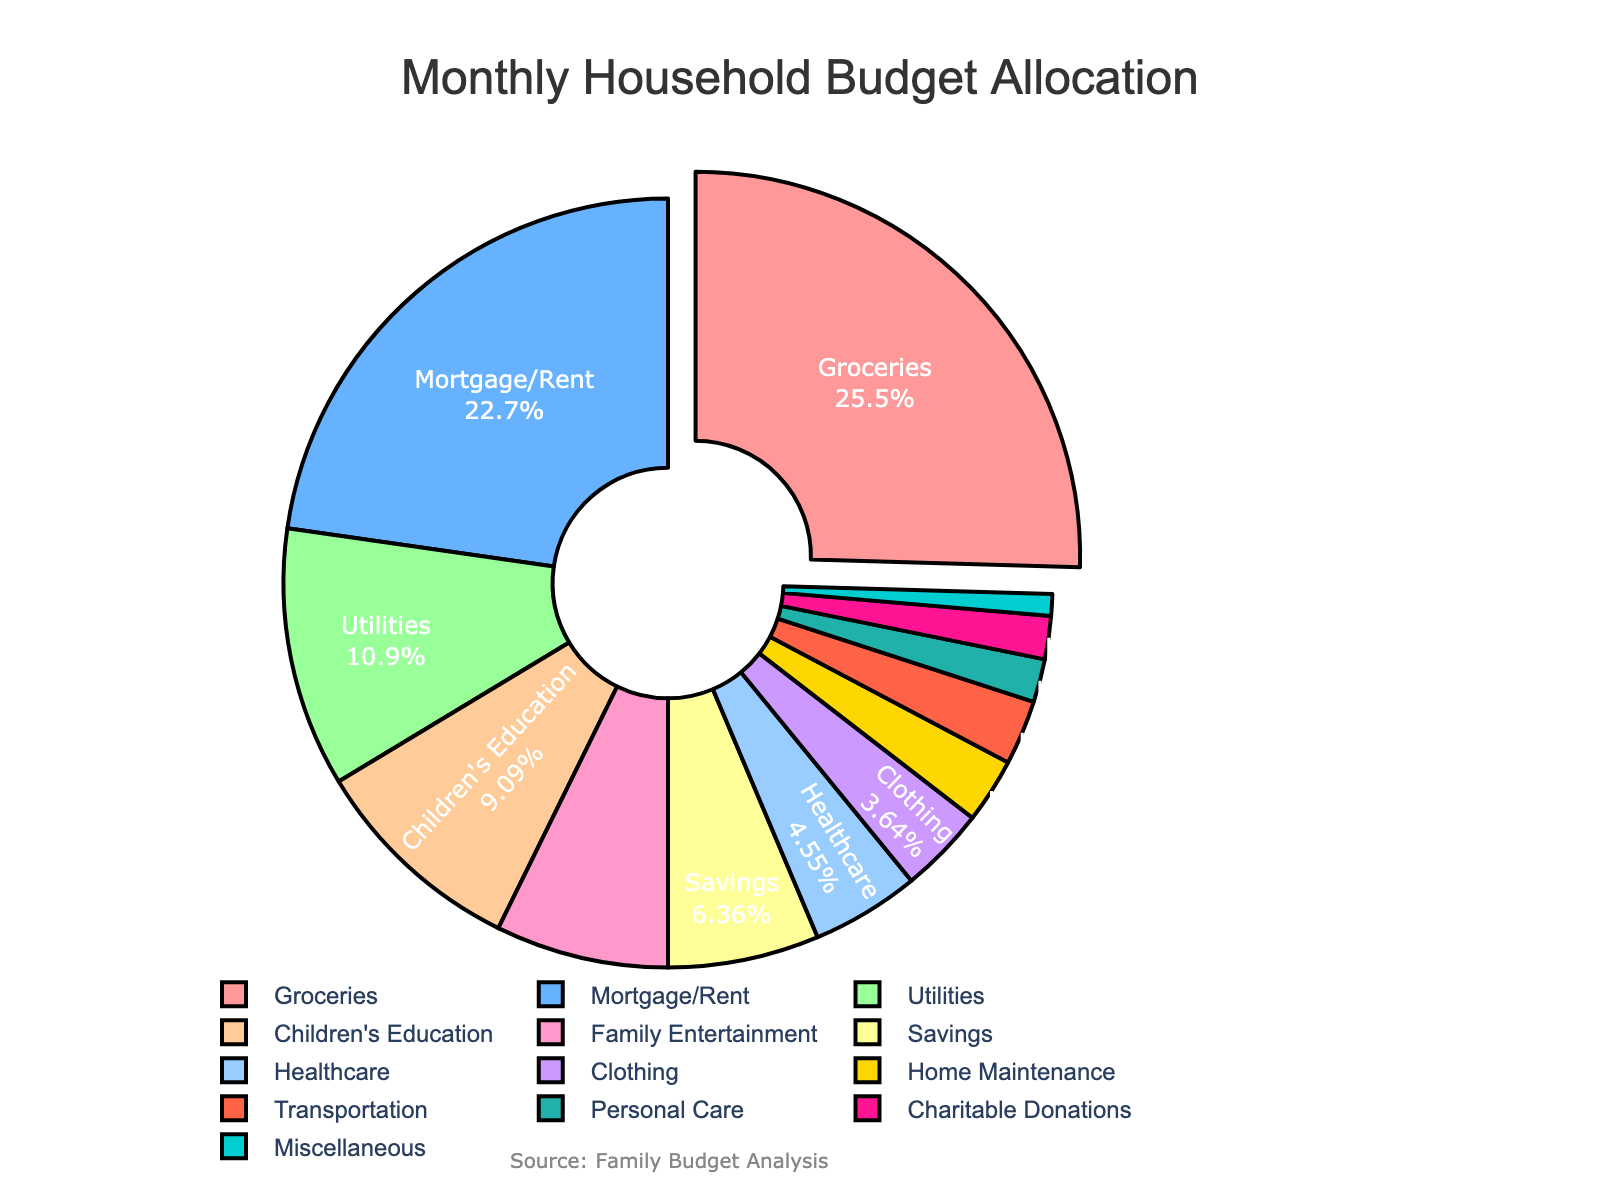What's the largest category in the household budget? The largest portion in the pie chart is indicated by the slice that is pulled out. In this chart, the Groceries category is pulled out and occupies the largest portion.
Answer: Groceries Which category accounts for the smallest percentage of the household budget? The smallest slice in the pie chart represents Miscellaneous, occupying just 1% of the household budget.
Answer: Miscellaneous How much more is spent on Groceries compared to Savings? Groceries account for 28% of the budget and Savings account for 7%. The difference is 28% - 7% = 21%.
Answer: 21% What percentage of the budget is allocated to children's education and family entertainment combined? Children’s Education is 10% and Family Entertainment is 8%. Summing these gives 10% + 8% = 18%.
Answer: 18% Which category has a slightly smaller budget allocation than Mortgage/Rent? Looking at the pie chart, Utilities is the category that is slightly smaller at 12% compared to Mortgage/Rent at 25%.
Answer: Utilities How do Healthcare and Clothing allocations compare percentage-wise? The pie chart shows Healthcare at 5% and Clothing at 4%. Healthcare is 1% higher than Clothing.
Answer: Healthcare is higher by 1% Among the categories, what is the total percentage allocated to transportation, home maintenance, and personal care? Transportation is 3%, Home Maintenance is 3%, and Personal Care is 2%. Summing these gives 3% + 3% + 2% = 8%.
Answer: 8% If you combine Mortgage/Rent and Utilities, how does this combined segment compare to the Groceries segment? Mortgage/Rent is 25% and Utilities is 12%. Their combined total is 25% + 12% = 37%. Groceries is 28%. Therefore, 37% is greater than 28%.
Answer: The combined segment is greater What is the color of the Family Entertainment section in the chart? The pie segment representing Family Entertainment is shown in a specific color. From the color palette provided, Family Entertainment is shown in pink.
Answer: Pink What portion of the budget is used for savings and charitable donations together? Savings constitute 7% and Charitable Donations make up 2%. Adding these values gives 7% + 2% = 9%.
Answer: 9% 